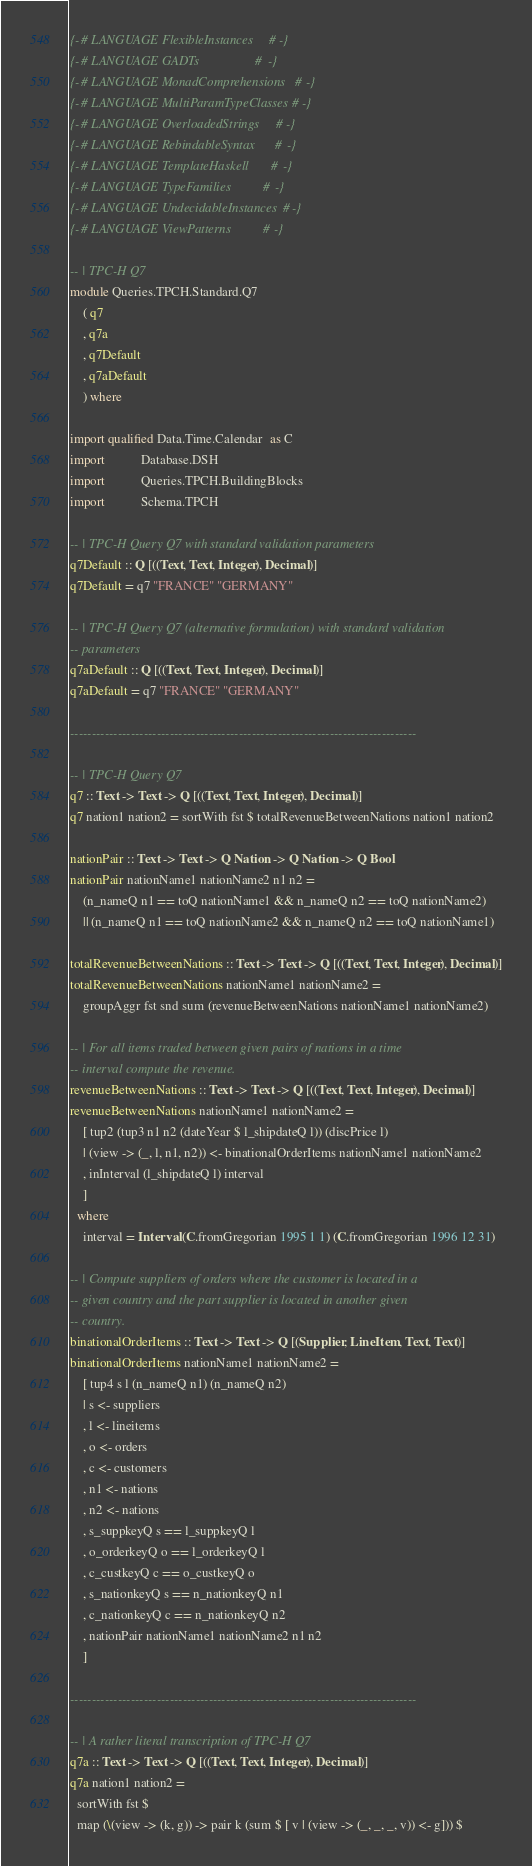Convert code to text. <code><loc_0><loc_0><loc_500><loc_500><_Haskell_>{-# LANGUAGE FlexibleInstances     #-}
{-# LANGUAGE GADTs                 #-}
{-# LANGUAGE MonadComprehensions   #-}
{-# LANGUAGE MultiParamTypeClasses #-}
{-# LANGUAGE OverloadedStrings     #-}
{-# LANGUAGE RebindableSyntax      #-}
{-# LANGUAGE TemplateHaskell       #-}
{-# LANGUAGE TypeFamilies          #-}
{-# LANGUAGE UndecidableInstances  #-}
{-# LANGUAGE ViewPatterns          #-}

-- | TPC-H Q7
module Queries.TPCH.Standard.Q7
    ( q7
    , q7a
    , q7Default
    , q7aDefault
    ) where

import qualified Data.Time.Calendar  as C
import           Database.DSH
import           Queries.TPCH.BuildingBlocks
import           Schema.TPCH

-- | TPC-H Query Q7 with standard validation parameters
q7Default :: Q [((Text, Text, Integer), Decimal)]
q7Default = q7 "FRANCE" "GERMANY"

-- | TPC-H Query Q7 (alternative formulation) with standard validation
-- parameters
q7aDefault :: Q [((Text, Text, Integer), Decimal)]
q7aDefault = q7 "FRANCE" "GERMANY"

--------------------------------------------------------------------------------

-- | TPC-H Query Q7
q7 :: Text -> Text -> Q [((Text, Text, Integer), Decimal)]
q7 nation1 nation2 = sortWith fst $ totalRevenueBetweenNations nation1 nation2

nationPair :: Text -> Text -> Q Nation -> Q Nation -> Q Bool
nationPair nationName1 nationName2 n1 n2 =
    (n_nameQ n1 == toQ nationName1 && n_nameQ n2 == toQ nationName2)
    || (n_nameQ n1 == toQ nationName2 && n_nameQ n2 == toQ nationName1)

totalRevenueBetweenNations :: Text -> Text -> Q [((Text, Text, Integer), Decimal)]
totalRevenueBetweenNations nationName1 nationName2 =
    groupAggr fst snd sum (revenueBetweenNations nationName1 nationName2)

-- | For all items traded between given pairs of nations in a time
-- interval compute the revenue.
revenueBetweenNations :: Text -> Text -> Q [((Text, Text, Integer), Decimal)]
revenueBetweenNations nationName1 nationName2 =
    [ tup2 (tup3 n1 n2 (dateYear $ l_shipdateQ l)) (discPrice l)
    | (view -> (_, l, n1, n2)) <- binationalOrderItems nationName1 nationName2
    , inInterval (l_shipdateQ l) interval
    ]
  where
    interval = Interval (C.fromGregorian 1995 1 1) (C.fromGregorian 1996 12 31)

-- | Compute suppliers of orders where the customer is located in a
-- given country and the part supplier is located in another given
-- country.
binationalOrderItems :: Text -> Text -> Q [(Supplier, LineItem, Text, Text)]
binationalOrderItems nationName1 nationName2 =
    [ tup4 s l (n_nameQ n1) (n_nameQ n2)
    | s <- suppliers
    , l <- lineitems
    , o <- orders
    , c <- customers
    , n1 <- nations
    , n2 <- nations
    , s_suppkeyQ s == l_suppkeyQ l
    , o_orderkeyQ o == l_orderkeyQ l
    , c_custkeyQ c == o_custkeyQ o
    , s_nationkeyQ s == n_nationkeyQ n1
    , c_nationkeyQ c == n_nationkeyQ n2
    , nationPair nationName1 nationName2 n1 n2
    ]

--------------------------------------------------------------------------------

-- | A rather literal transcription of TPC-H Q7
q7a :: Text -> Text -> Q [((Text, Text, Integer), Decimal)]
q7a nation1 nation2 =
  sortWith fst $
  map (\(view -> (k, g)) -> pair k (sum $ [ v | (view -> (_, _, _, v)) <- g])) $</code> 